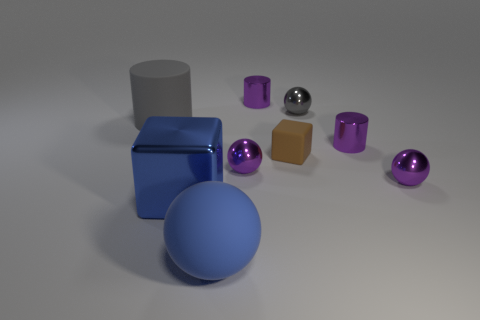Subtract all purple cubes. How many purple balls are left? 2 Subtract all large cylinders. How many cylinders are left? 2 Subtract 2 balls. How many balls are left? 2 Subtract all blue balls. How many balls are left? 3 Subtract all green cylinders. Subtract all blue blocks. How many cylinders are left? 3 Subtract all cylinders. How many objects are left? 6 Subtract all gray rubber things. Subtract all big cylinders. How many objects are left? 7 Add 6 small blocks. How many small blocks are left? 7 Add 8 gray matte objects. How many gray matte objects exist? 9 Subtract 0 green balls. How many objects are left? 9 